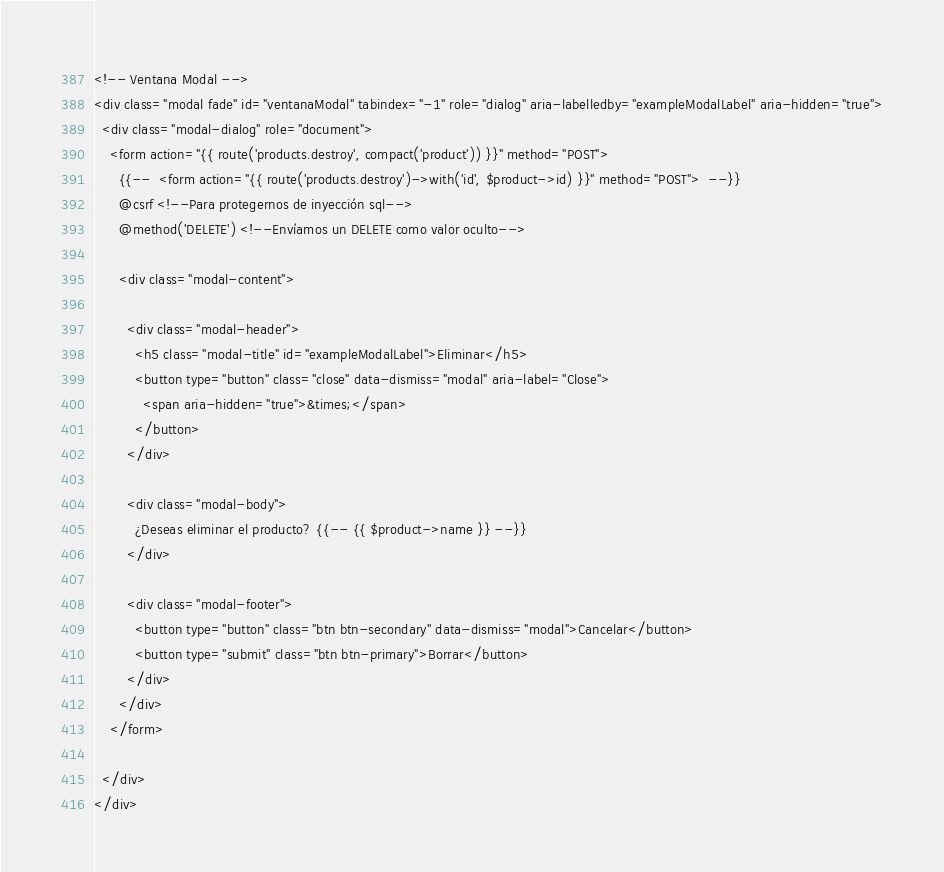<code> <loc_0><loc_0><loc_500><loc_500><_PHP_><!-- Ventana Modal -->
<div class="modal fade" id="ventanaModal" tabindex="-1" role="dialog" aria-labelledby="exampleModalLabel" aria-hidden="true">
  <div class="modal-dialog" role="document">
    <form action="{{ route('products.destroy', compact('product')) }}" method="POST"> 
      {{--  <form action="{{ route('products.destroy')->with('id', $product->id) }}" method="POST">  --}}
      @csrf <!--Para protegernos de inyección sql-->
      @method('DELETE') <!--Envíamos un DELETE como valor oculto-->

      <div class="modal-content">

        <div class="modal-header">
          <h5 class="modal-title" id="exampleModalLabel">Eliminar</h5>
          <button type="button" class="close" data-dismiss="modal" aria-label="Close">
            <span aria-hidden="true">&times;</span>
          </button>
        </div>

        <div class="modal-body">
          ¿Deseas eliminar el producto? {{-- {{ $product->name }} --}}
        </div>

        <div class="modal-footer">
          <button type="button" class="btn btn-secondary" data-dismiss="modal">Cancelar</button>
          <button type="submit" class="btn btn-primary">Borrar</button>
        </div>
      </div>
    </form>

  </div>
</div></code> 